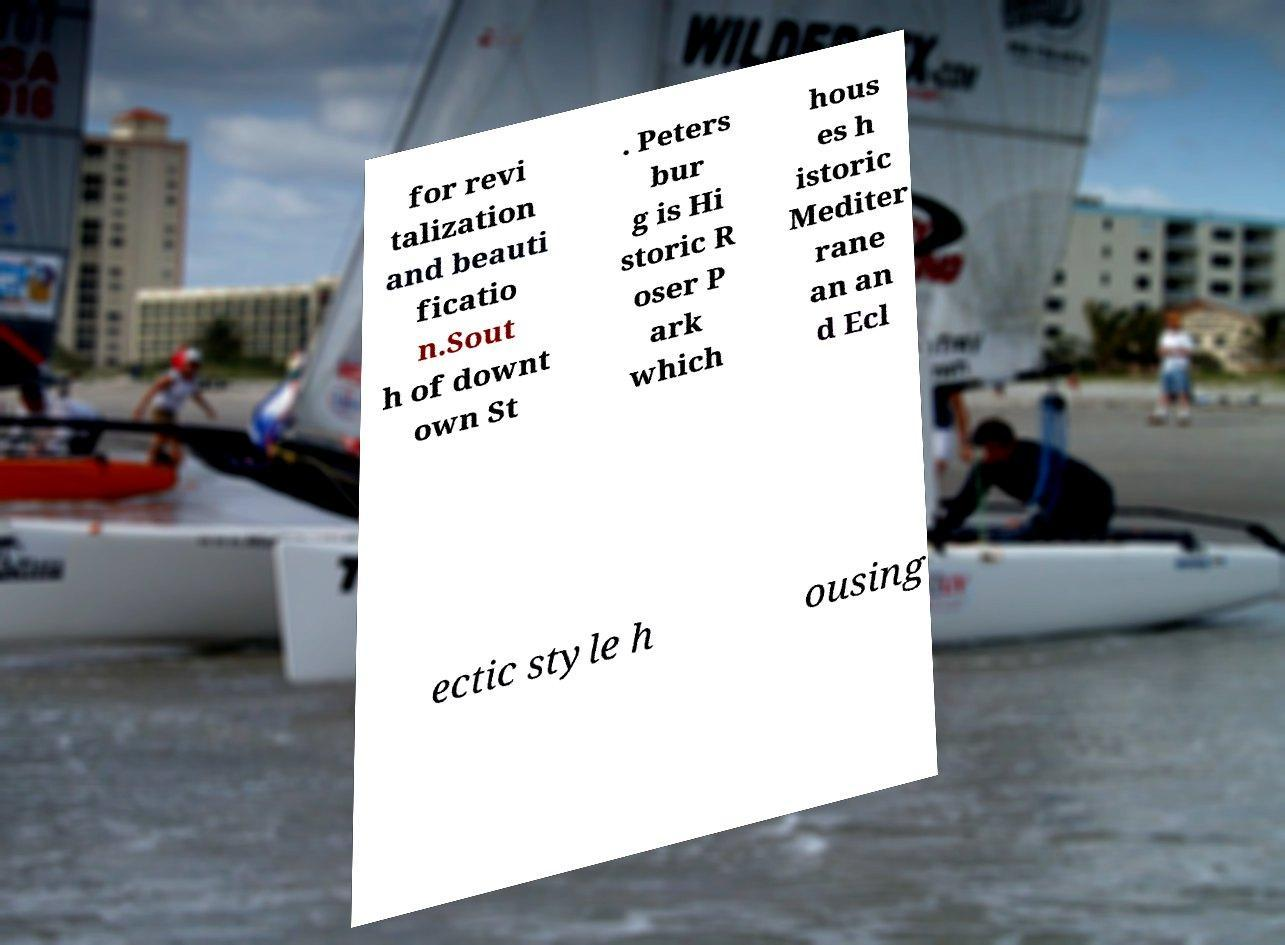Can you accurately transcribe the text from the provided image for me? for revi talization and beauti ficatio n.Sout h of downt own St . Peters bur g is Hi storic R oser P ark which hous es h istoric Mediter rane an an d Ecl ectic style h ousing 